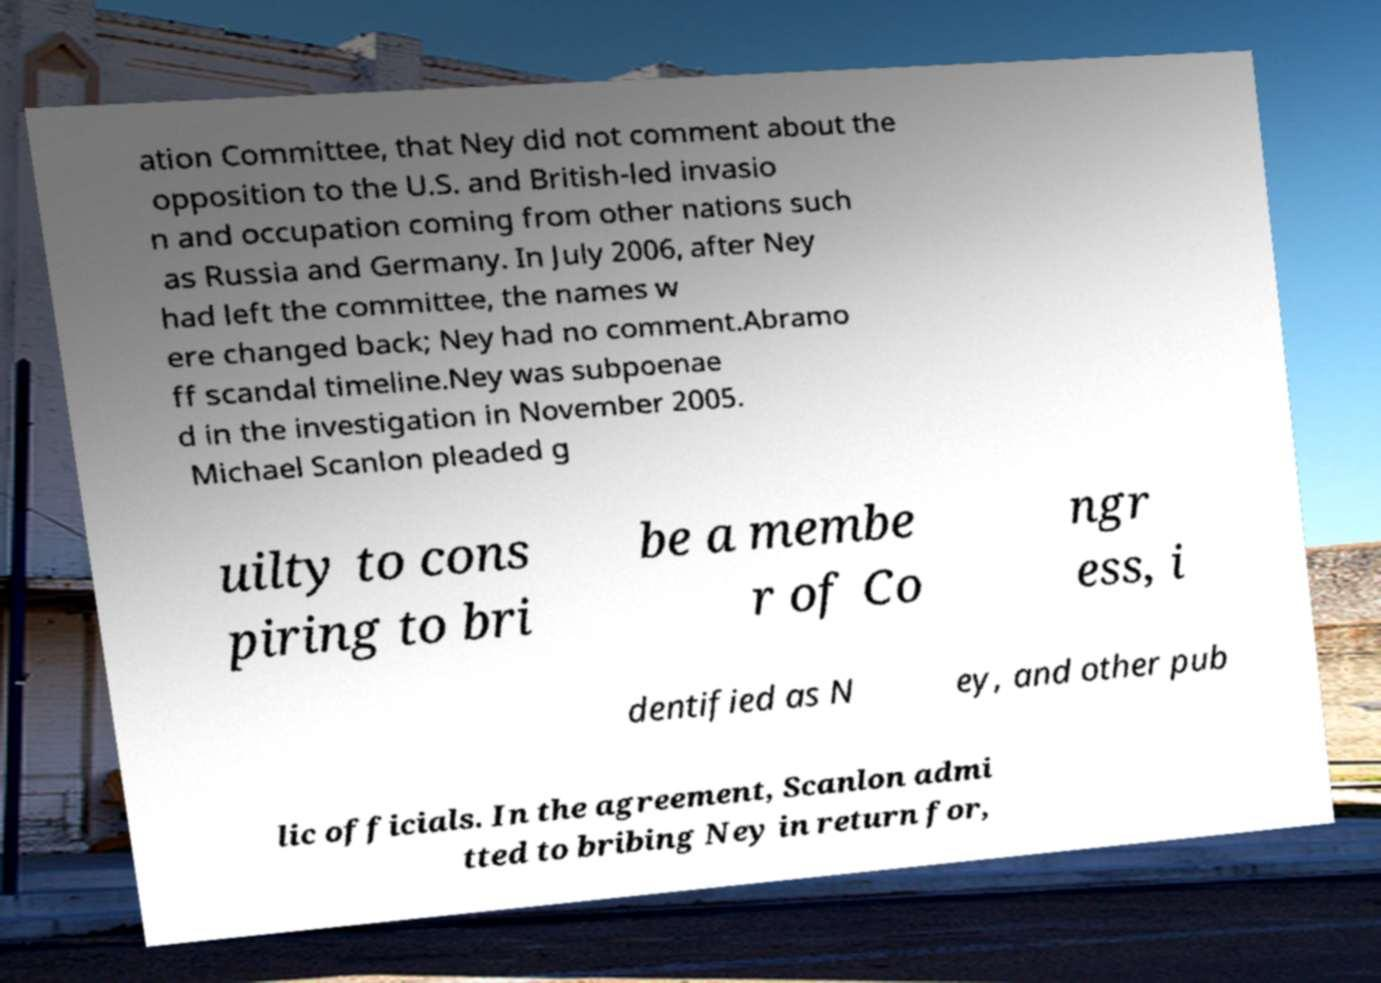Could you assist in decoding the text presented in this image and type it out clearly? ation Committee, that Ney did not comment about the opposition to the U.S. and British-led invasio n and occupation coming from other nations such as Russia and Germany. In July 2006, after Ney had left the committee, the names w ere changed back; Ney had no comment.Abramo ff scandal timeline.Ney was subpoenae d in the investigation in November 2005. Michael Scanlon pleaded g uilty to cons piring to bri be a membe r of Co ngr ess, i dentified as N ey, and other pub lic officials. In the agreement, Scanlon admi tted to bribing Ney in return for, 